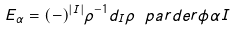Convert formula to latex. <formula><loc_0><loc_0><loc_500><loc_500>E _ { \alpha } = ( - ) ^ { | I | } \rho ^ { - 1 } d _ { I } \rho \ p a r d e r { } { \phi } { \alpha } { I }</formula> 